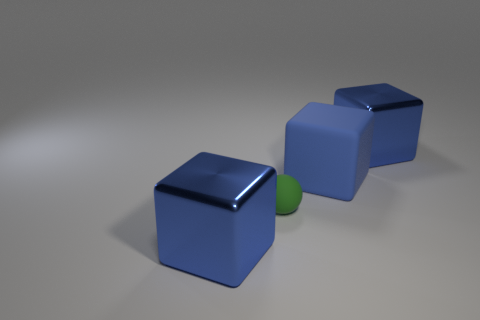How many objects are large blue cubes in front of the big blue rubber block or large cubes in front of the sphere?
Give a very brief answer. 1. Do the large metal thing that is on the right side of the green matte object and the blue metallic object that is to the left of the tiny green matte object have the same shape?
Your answer should be very brief. Yes. How many metallic things are either purple things or spheres?
Offer a very short reply. 0. Is the big cube that is to the left of the small rubber object made of the same material as the big block that is behind the blue rubber cube?
Your answer should be compact. Yes. There is another thing that is made of the same material as the tiny green thing; what color is it?
Offer a very short reply. Blue. Is the number of big cubes that are left of the green matte ball greater than the number of blue blocks right of the large matte thing?
Keep it short and to the point. No. Is there a large metallic object?
Ensure brevity in your answer.  Yes. How many objects are either large cyan cylinders or large cubes?
Keep it short and to the point. 3. Are there any metallic objects that have the same color as the big matte block?
Give a very brief answer. Yes. How many big metal things are behind the big blue metallic object that is behind the blue rubber thing?
Your response must be concise. 0. 